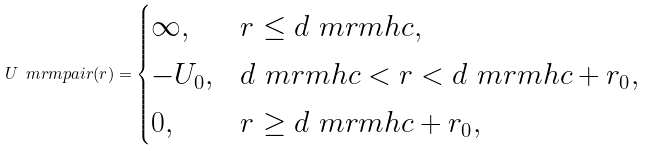Convert formula to latex. <formula><loc_0><loc_0><loc_500><loc_500>U _ { \ } m r m { p a i r } ( r ) = \begin{cases} \infty , & r \leq d _ { \ } m r m { h c } , \\ - U _ { 0 } , & d _ { \ } m r m { h c } < r < d _ { \ } m r m { h c } + r _ { 0 } , \\ 0 , & r \geq d _ { \ } m r m { h c } + r _ { 0 } , \end{cases}</formula> 